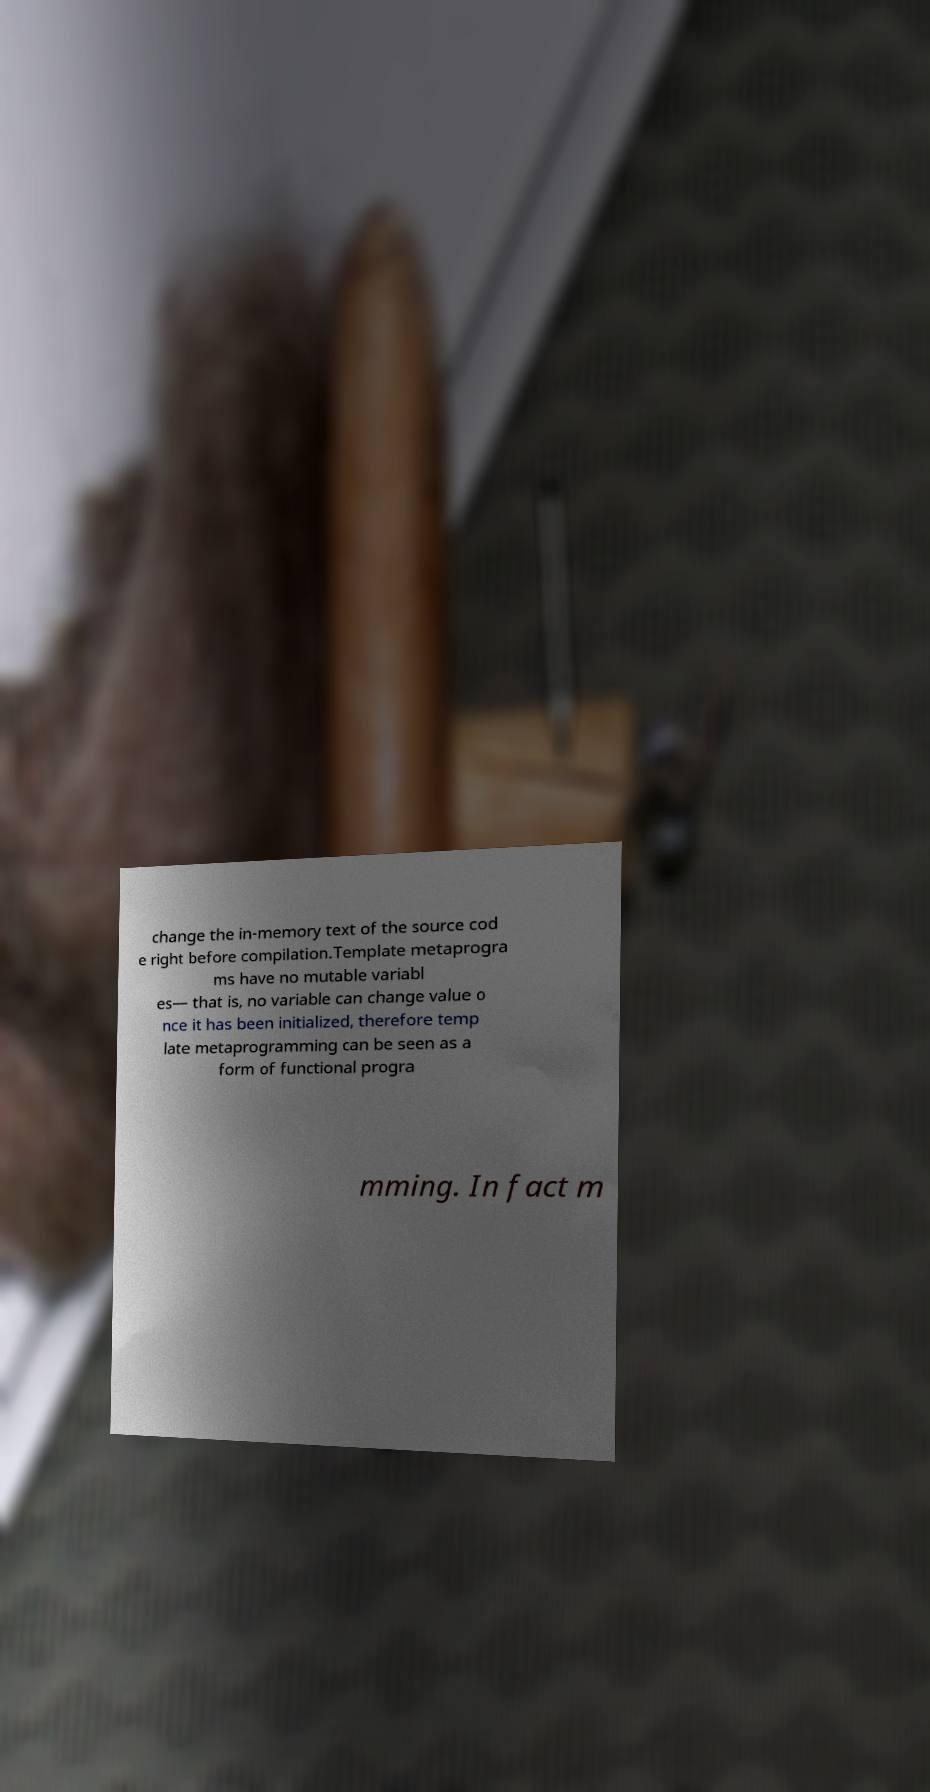Can you read and provide the text displayed in the image?This photo seems to have some interesting text. Can you extract and type it out for me? change the in-memory text of the source cod e right before compilation.Template metaprogra ms have no mutable variabl es— that is, no variable can change value o nce it has been initialized, therefore temp late metaprogramming can be seen as a form of functional progra mming. In fact m 